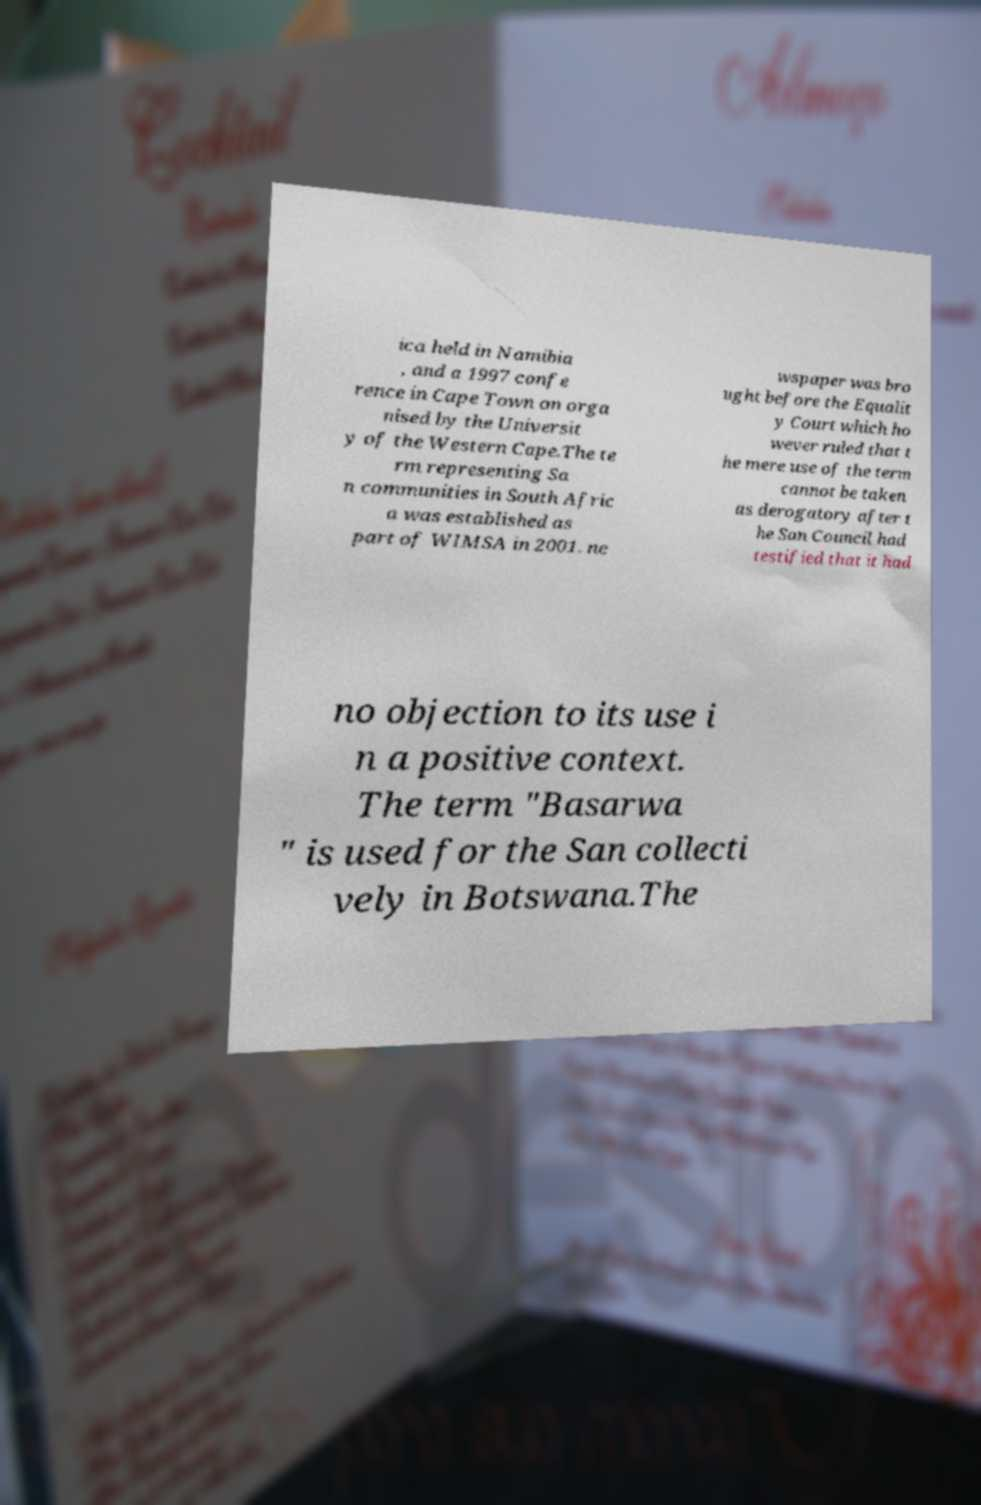Could you assist in decoding the text presented in this image and type it out clearly? ica held in Namibia , and a 1997 confe rence in Cape Town on orga nised by the Universit y of the Western Cape.The te rm representing Sa n communities in South Afric a was established as part of WIMSA in 2001. ne wspaper was bro ught before the Equalit y Court which ho wever ruled that t he mere use of the term cannot be taken as derogatory after t he San Council had testified that it had no objection to its use i n a positive context. The term "Basarwa " is used for the San collecti vely in Botswana.The 